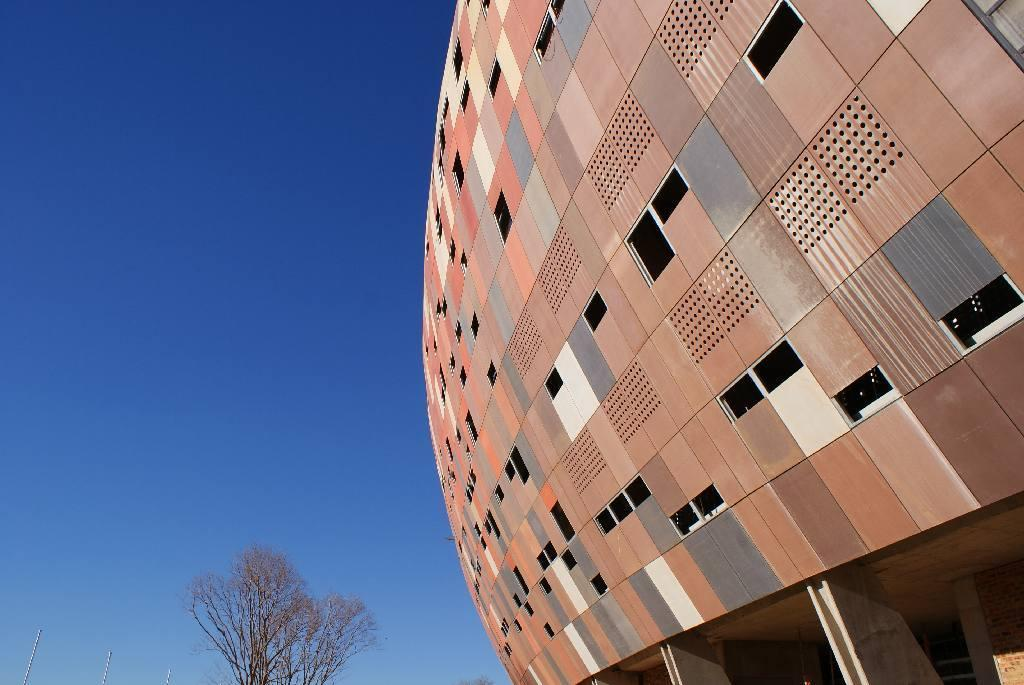What is there is a building in the foreground of the image, what can you tell me about it? There is a building in the foreground of the image. What can be seen in the background of the image? There are trees and poles in the background of the image. What is visible in the sky in the image? The sky is visible in the background of the image. What type of glass is being used to make the wilderness in the image? There is no glass or wilderness present in the image. What type of joke is being told by the trees in the image? There are no jokes being told by the trees in the image. 